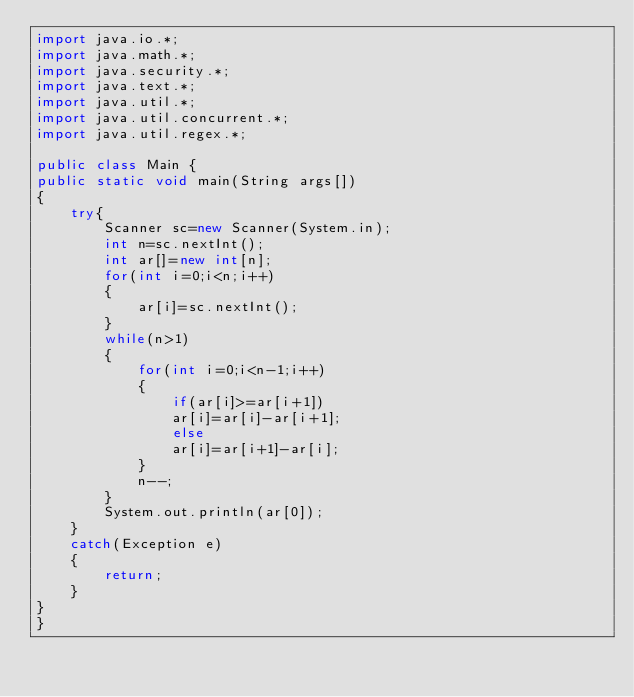Convert code to text. <code><loc_0><loc_0><loc_500><loc_500><_Java_>import java.io.*;
import java.math.*;
import java.security.*;
import java.text.*;
import java.util.*;
import java.util.concurrent.*;
import java.util.regex.*;

public class Main {
public static void main(String args[])
{
    try{
        Scanner sc=new Scanner(System.in);
        int n=sc.nextInt();
        int ar[]=new int[n];
        for(int i=0;i<n;i++)
        {
            ar[i]=sc.nextInt();
        }
        while(n>1)
        {
            for(int i=0;i<n-1;i++)
            {
                if(ar[i]>=ar[i+1])
                ar[i]=ar[i]-ar[i+1];
                else
                ar[i]=ar[i+1]-ar[i];
            }
            n--;
        }
        System.out.println(ar[0]);
    }
    catch(Exception e)
    {
        return;
    }
}
}</code> 